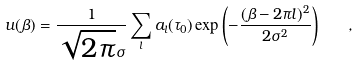Convert formula to latex. <formula><loc_0><loc_0><loc_500><loc_500>u ( \beta ) = \frac { 1 } { \sqrt { 2 \pi } \sigma } \sum _ { l } a _ { l } ( \tau _ { 0 } ) \exp \left ( - \frac { ( \beta - 2 \pi l ) ^ { 2 } } { 2 \sigma ^ { 2 } } \right ) \quad ,</formula> 